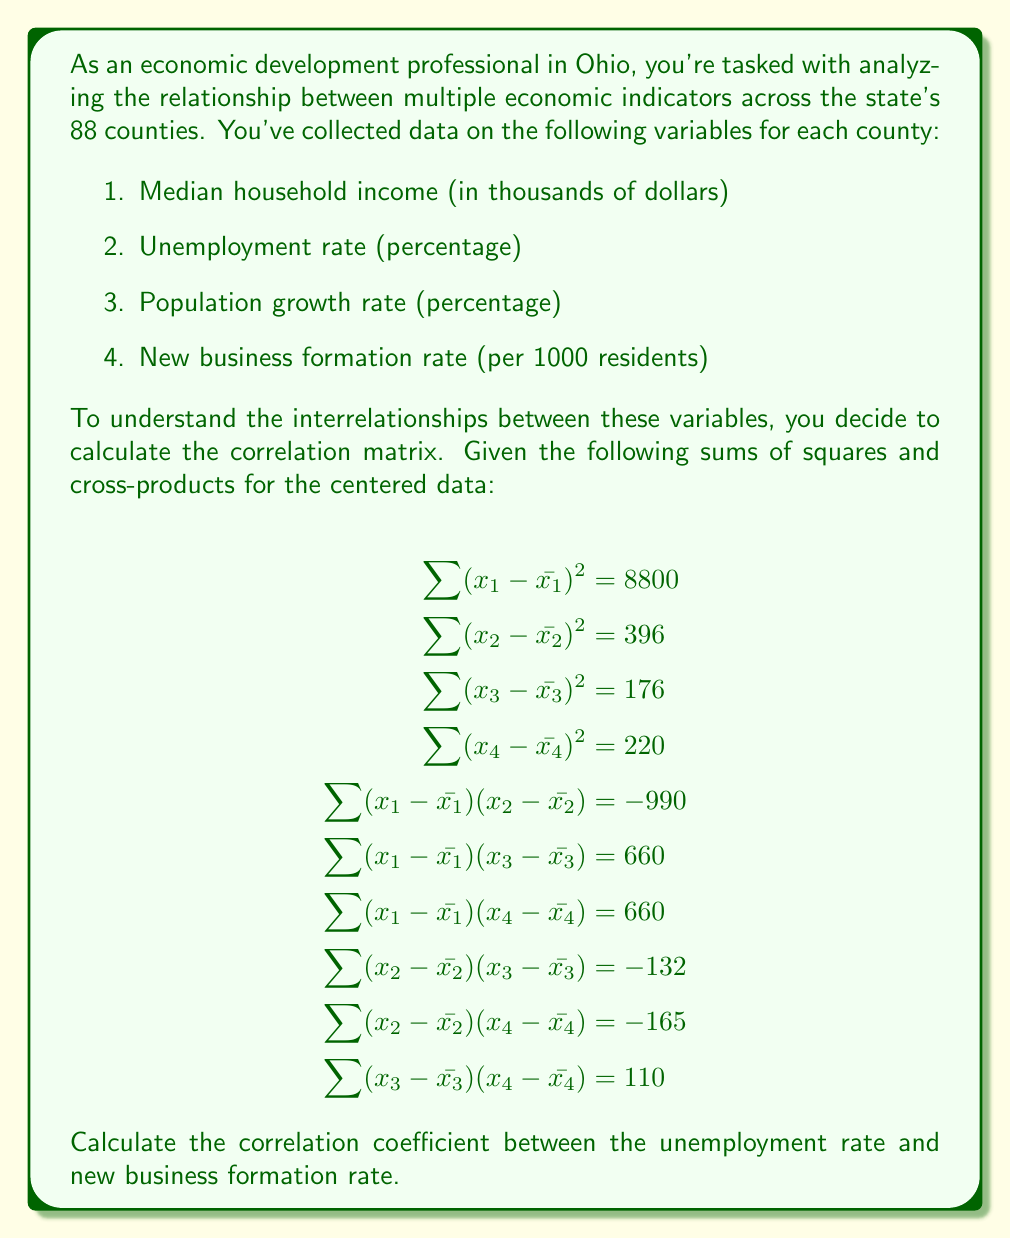Solve this math problem. To solve this problem, we'll follow these steps:

1. Recall the formula for the correlation coefficient:

   $$r_{xy} = \frac{\sum (x - \bar{x})(y - \bar{y})}{\sqrt{\sum (x - \bar{x})^2 \sum (y - \bar{y})^2}}$$

2. Identify the relevant variables:
   - Unemployment rate (x_2)
   - New business formation rate (x_4)

3. Find the necessary values from the given data:
   $$\begin{align}
   \sum (x_2 - \bar{x_2})^2 &= 396 \\
   \sum (x_4 - \bar{x_4})^2 &= 220 \\
   \sum (x_2 - \bar{x_2})(x_4 - \bar{x_4}) &= -165
   \end{align}$$

4. Plug these values into the correlation coefficient formula:

   $$r_{24} = \frac{-165}{\sqrt{396 \times 220}}$$

5. Calculate the result:
   $$\begin{align}
   r_{24} &= \frac{-165}{\sqrt{87120}} \\
   &= \frac{-165}{295.16} \\
   &\approx -0.5590
   \end{align}$$

The correlation coefficient between the unemployment rate and new business formation rate is approximately -0.5590.

This negative correlation indicates that as the unemployment rate increases, the new business formation rate tends to decrease, and vice versa. The magnitude of about 0.56 suggests a moderate strength of this relationship.
Answer: $r_{24} \approx -0.5590$ 